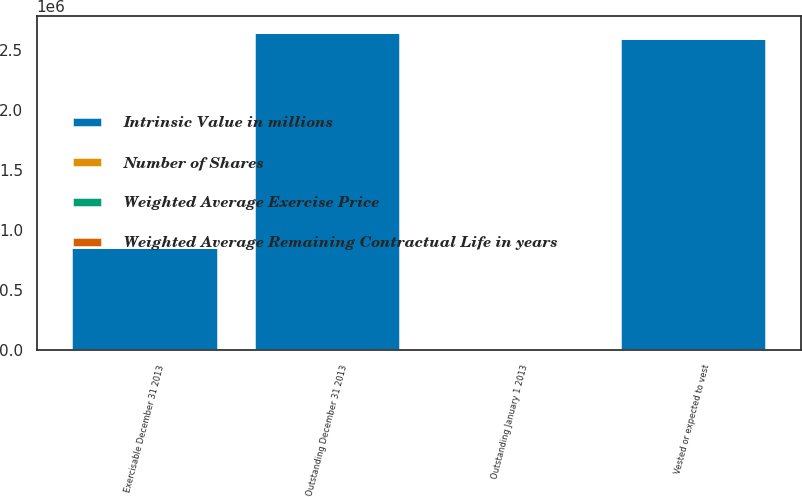Convert chart. <chart><loc_0><loc_0><loc_500><loc_500><stacked_bar_chart><ecel><fcel>Outstanding January 1 2013<fcel>Outstanding December 31 2013<fcel>Vested or expected to vest<fcel>Exercisable December 31 2013<nl><fcel>Intrinsic Value in millions<fcel>88.08<fcel>2.64439e+06<fcel>2.59559e+06<fcel>862065<nl><fcel>Weighted Average Exercise Price<fcel>71.34<fcel>88.08<fcel>87.76<fcel>60.49<nl><fcel>Number of Shares<fcel>6.6<fcel>6.9<fcel>6.8<fcel>4.3<nl><fcel>Weighted Average Remaining Contractual Life in years<fcel>218<fcel>269<fcel>265<fcel>111<nl></chart> 